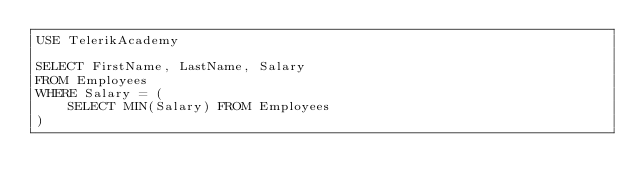<code> <loc_0><loc_0><loc_500><loc_500><_SQL_>USE TelerikAcademy

SELECT FirstName, LastName, Salary
FROM Employees
WHERE Salary = (
	SELECT MIN(Salary) FROM Employees
)</code> 